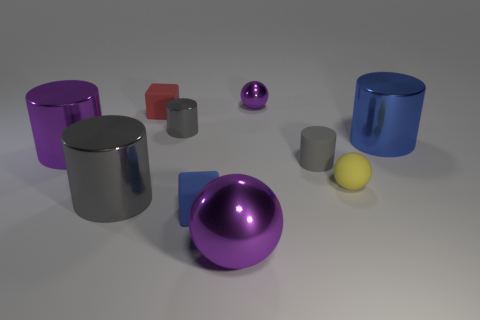What number of small metallic objects are in front of the tiny purple sphere?
Keep it short and to the point. 1. What is the material of the small blue block?
Ensure brevity in your answer.  Rubber. The tiny sphere that is right of the tiny gray cylinder right of the purple thing behind the large blue object is what color?
Provide a short and direct response. Yellow. How many blue matte cubes are the same size as the yellow rubber thing?
Your response must be concise. 1. What color is the shiny ball that is on the left side of the tiny metal ball?
Provide a succinct answer. Purple. What number of other objects are there of the same size as the yellow rubber thing?
Ensure brevity in your answer.  5. How big is the purple metallic thing that is right of the small blue object and behind the yellow ball?
Ensure brevity in your answer.  Small. There is a small metallic sphere; is it the same color as the shiny ball that is in front of the big purple cylinder?
Give a very brief answer. Yes. Are there any small blue metallic things that have the same shape as the small yellow rubber object?
Ensure brevity in your answer.  No. How many objects are either big purple objects or matte things to the left of the rubber cylinder?
Offer a very short reply. 4. 